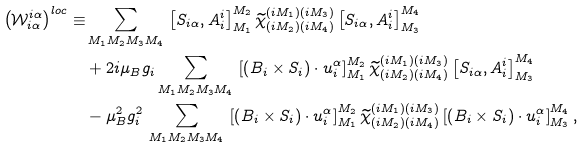<formula> <loc_0><loc_0><loc_500><loc_500>\left ( \mathcal { W } ^ { i \alpha } _ { i \alpha } \right ) ^ { l o c } \equiv & \sum _ { M _ { 1 } M _ { 2 } M _ { 3 } M _ { 4 } } \, \left [ S _ { i \alpha } , A ^ { i } _ { i } \right ] ^ { M _ { 2 } } _ { M _ { 1 } } \widetilde { \chi } ^ { ( i M _ { 1 } ) ( i M _ { 3 } ) } _ { ( i M _ { 2 } ) ( i M _ { 4 } ) } \left [ S _ { i \alpha } , A ^ { i } _ { i } \right ] ^ { M _ { 4 } } _ { M _ { 3 } } \\ & + 2 i \mu _ { B } g _ { i } \sum _ { M _ { 1 } M _ { 2 } M _ { 3 } M _ { 4 } } \, \left [ \left ( B _ { i } \times S _ { i } \right ) \cdot u _ { i } ^ { \alpha } \right ] ^ { M _ { 2 } } _ { M _ { 1 } } \widetilde { \chi } ^ { ( i M _ { 1 } ) ( i M _ { 3 } ) } _ { ( i M _ { 2 } ) ( i M _ { 4 } ) } \left [ S _ { i \alpha } , A ^ { i } _ { i } \right ] ^ { M _ { 4 } } _ { M _ { 3 } } \\ & - \mu _ { B } ^ { 2 } g _ { i } ^ { 2 } \, \sum _ { M _ { 1 } M _ { 2 } M _ { 3 } M _ { 4 } } \, \left [ \left ( B _ { i } \times S _ { i } \right ) \cdot u _ { i } ^ { \alpha } \right ] ^ { M _ { 2 } } _ { M _ { 1 } } \widetilde { \chi } ^ { ( i M _ { 1 } ) ( i M _ { 3 } ) } _ { ( i M _ { 2 } ) ( i M _ { 4 } ) } \left [ \left ( B _ { i } \times S _ { i } \right ) \cdot u _ { i } ^ { \alpha } \right ] ^ { M _ { 4 } } _ { M _ { 3 } } ,</formula> 